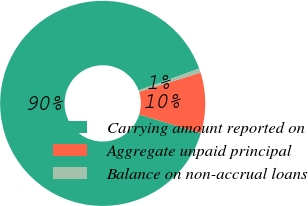Convert chart. <chart><loc_0><loc_0><loc_500><loc_500><pie_chart><fcel>Carrying amount reported on<fcel>Aggregate unpaid principal<fcel>Balance on non-accrual loans<nl><fcel>89.8%<fcel>9.56%<fcel>0.64%<nl></chart> 